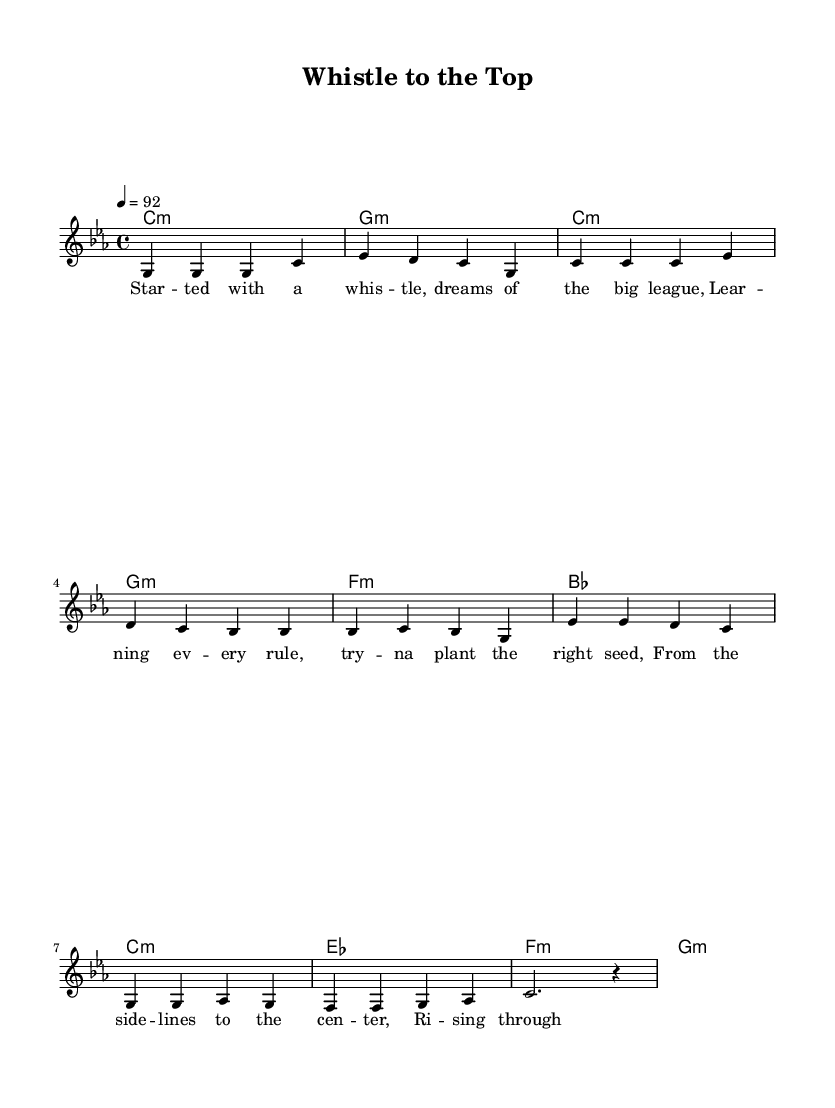What is the key signature of this music? The key signature is C minor, which has three flats (B♭, E♭, and A♭). This can be identified by looking at the beginning of the staff where the key signature is placed.
Answer: C minor What is the time signature of this music? The time signature is 4/4, which means there are four beats in each measure and the quarter note gets one beat. This is indicated at the beginning of the sheet music next to the key signature.
Answer: 4/4 What is the tempo marking in this piece? The tempo marking is indicated as "4 = 92," which specifies that there are 92 beats per minute in quarter note timing. This can be found at the top left corner of the sheet music.
Answer: 92 How many measures are in the verse section? The verse section consists of four measures, as seen by counting the measures in the corresponding part of the melody notation.
Answer: 4 Which chord appears most frequently in the verse? The chord that appears most frequently in the verse is C minor. This can be determined by analyzing the chord names written above the melody in the verse section.
Answer: C minor What is the significance of using a rap style in the lyrics? The use of rap style in the lyrics emphasizes rhythm and rhyme and helps convey the story in a compelling way. Rap relies on a strong rhythmic flow, which complements the lyrics about transitioning from amateur to professional soccer referee.
Answer: Rhythm and rhyme What type of musical format is used in the melody section? The melody section uses a vocal line format, suitable for rap, which often conveys speech-like rhythms and syllable stresses directly aligned with the lyrics' flow. This can be identified by observing the note arrangement and rhythmic patterns distinct to rap music.
Answer: Vocal line 